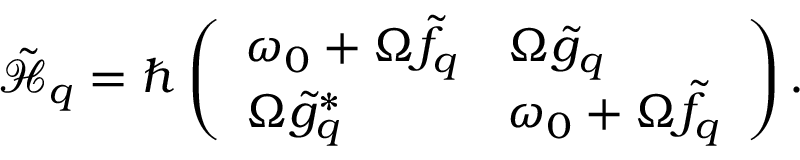Convert formula to latex. <formula><loc_0><loc_0><loc_500><loc_500>\tilde { \mathcal { H } } _ { q } = \hbar { \left } ( \begin{array} { l l } { \omega _ { 0 } + \Omega \tilde { f } _ { q } } & { \Omega \tilde { g } _ { q } } \\ { \Omega \tilde { g } _ { q } ^ { * } } & { \omega _ { 0 } + \Omega \tilde { f } _ { q } } \end{array} \right ) .</formula> 